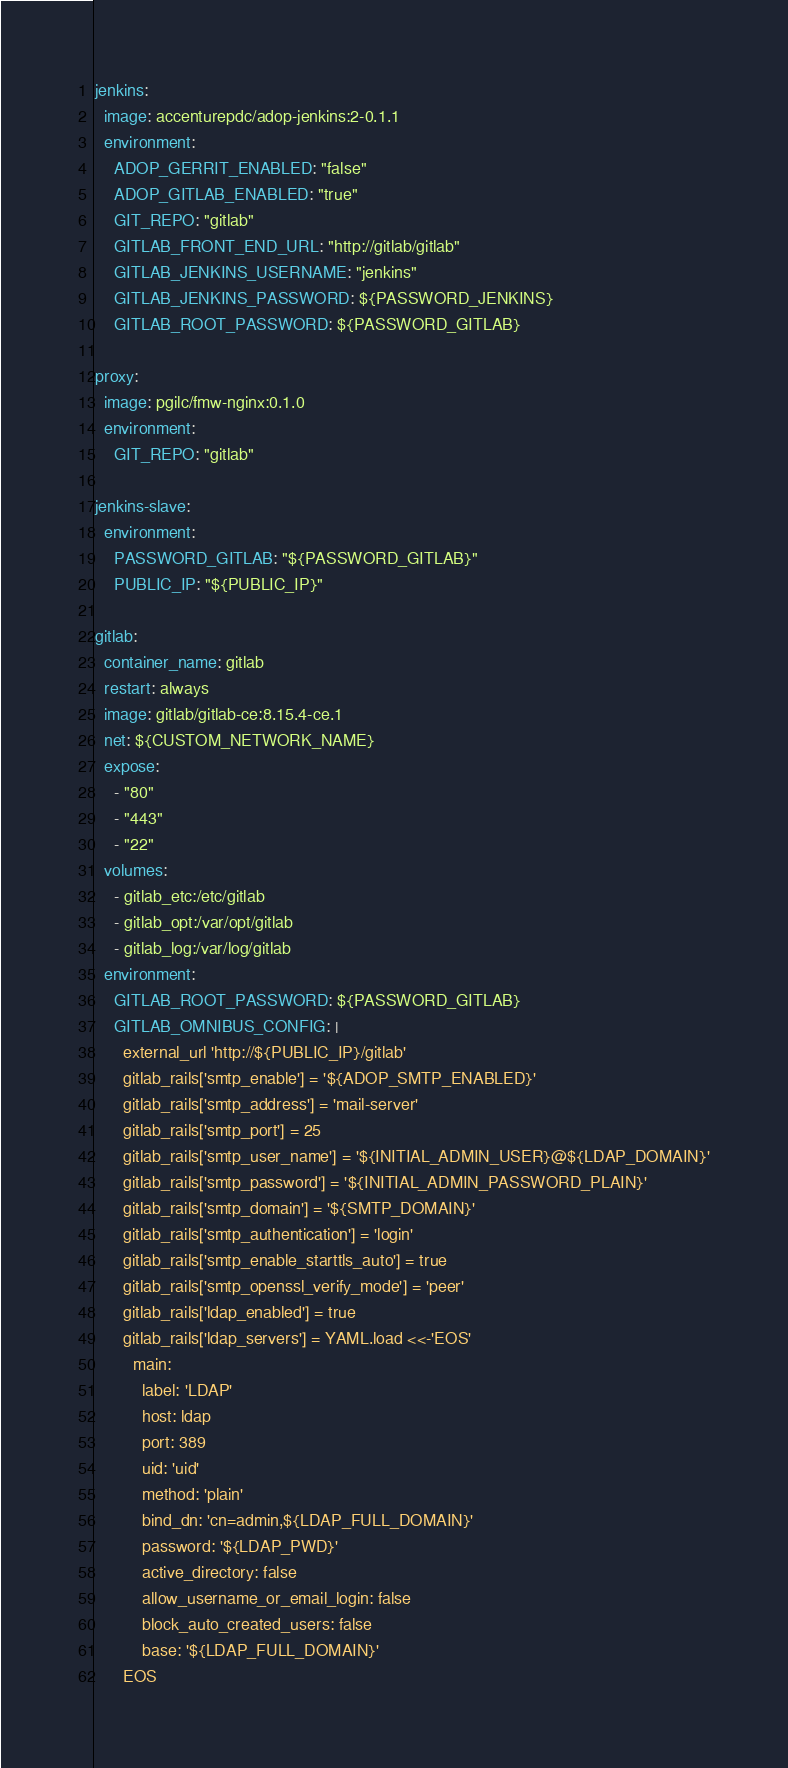Convert code to text. <code><loc_0><loc_0><loc_500><loc_500><_YAML_>jenkins:
  image: accenturepdc/adop-jenkins:2-0.1.1
  environment:
    ADOP_GERRIT_ENABLED: "false"
    ADOP_GITLAB_ENABLED: "true"
    GIT_REPO: "gitlab"
    GITLAB_FRONT_END_URL: "http://gitlab/gitlab"
    GITLAB_JENKINS_USERNAME: "jenkins"
    GITLAB_JENKINS_PASSWORD: ${PASSWORD_JENKINS}
    GITLAB_ROOT_PASSWORD: ${PASSWORD_GITLAB}

proxy:
  image: pgilc/fmw-nginx:0.1.0
  environment:
    GIT_REPO: "gitlab"

jenkins-slave:
  environment:
    PASSWORD_GITLAB: "${PASSWORD_GITLAB}"
    PUBLIC_IP: "${PUBLIC_IP}"

gitlab:
  container_name: gitlab
  restart: always
  image: gitlab/gitlab-ce:8.15.4-ce.1
  net: ${CUSTOM_NETWORK_NAME}
  expose:
    - "80"
    - "443"
    - "22"
  volumes:
    - gitlab_etc:/etc/gitlab
    - gitlab_opt:/var/opt/gitlab
    - gitlab_log:/var/log/gitlab
  environment:
    GITLAB_ROOT_PASSWORD: ${PASSWORD_GITLAB}
    GITLAB_OMNIBUS_CONFIG: |
      external_url 'http://${PUBLIC_IP}/gitlab'
      gitlab_rails['smtp_enable'] = '${ADOP_SMTP_ENABLED}'
      gitlab_rails['smtp_address'] = 'mail-server'
      gitlab_rails['smtp_port'] = 25
      gitlab_rails['smtp_user_name'] = '${INITIAL_ADMIN_USER}@${LDAP_DOMAIN}'
      gitlab_rails['smtp_password'] = '${INITIAL_ADMIN_PASSWORD_PLAIN}'
      gitlab_rails['smtp_domain'] = '${SMTP_DOMAIN}'
      gitlab_rails['smtp_authentication'] = 'login'
      gitlab_rails['smtp_enable_starttls_auto'] = true
      gitlab_rails['smtp_openssl_verify_mode'] = 'peer'
      gitlab_rails['ldap_enabled'] = true
      gitlab_rails['ldap_servers'] = YAML.load <<-'EOS'
        main:
          label: 'LDAP'
          host: ldap
          port: 389
          uid: 'uid'
          method: 'plain'
          bind_dn: 'cn=admin,${LDAP_FULL_DOMAIN}'
          password: '${LDAP_PWD}'
          active_directory: false
          allow_username_or_email_login: false
          block_auto_created_users: false
          base: '${LDAP_FULL_DOMAIN}'
      EOS

</code> 